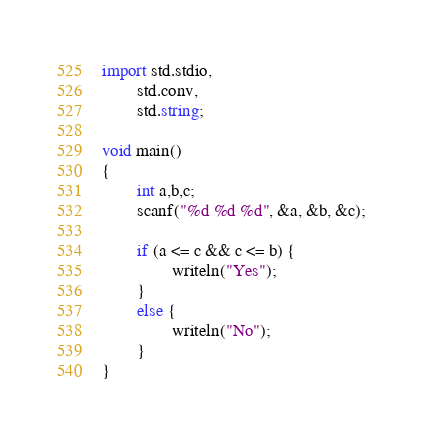Convert code to text. <code><loc_0><loc_0><loc_500><loc_500><_D_>import std.stdio,
        std.conv,
        std.string;

void main()
{
        int a,b,c;
        scanf("%d %d %d", &a, &b, &c);

        if (a <= c && c <= b) {
                writeln("Yes");
        }
        else {
                writeln("No");
        }
}</code> 